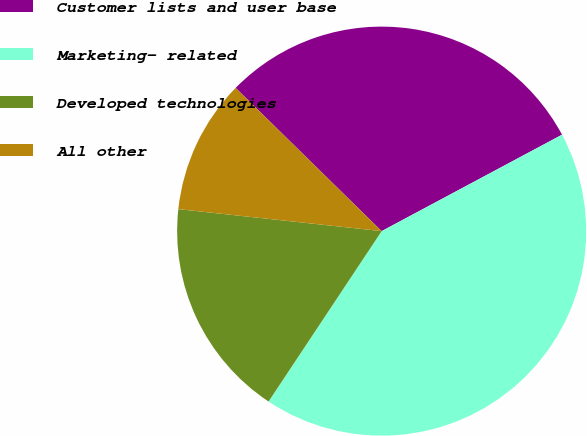Convert chart. <chart><loc_0><loc_0><loc_500><loc_500><pie_chart><fcel>Customer lists and user base<fcel>Marketing- related<fcel>Developed technologies<fcel>All other<nl><fcel>29.84%<fcel>42.14%<fcel>17.39%<fcel>10.63%<nl></chart> 